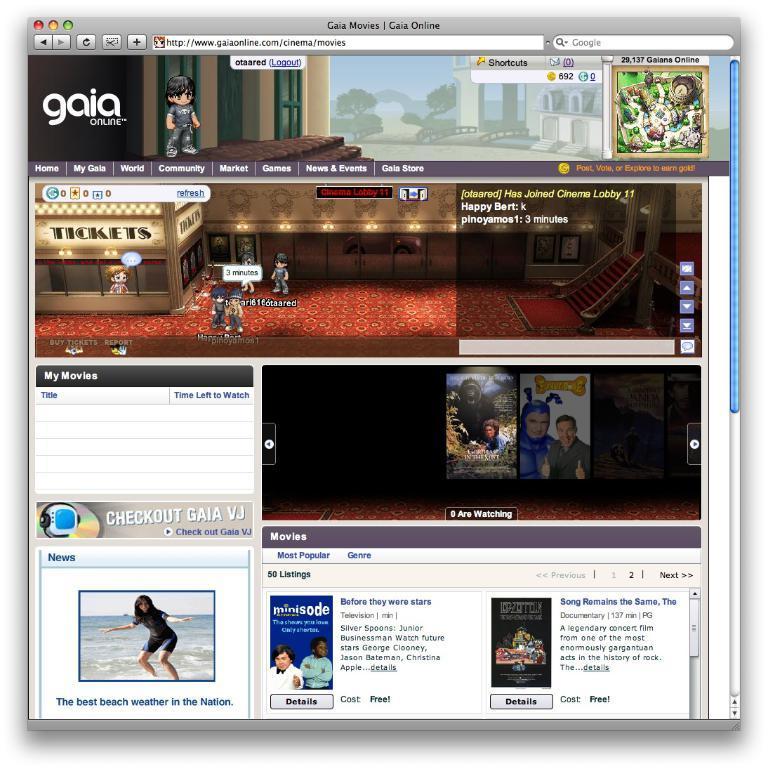In one or two sentences, can you explain what this image depicts? In this picture I can see a web page and few cartoon images and I can see pictures of few men and a woman and looks like few cover pages at the bottom of the picture and I can see text in the picture. 